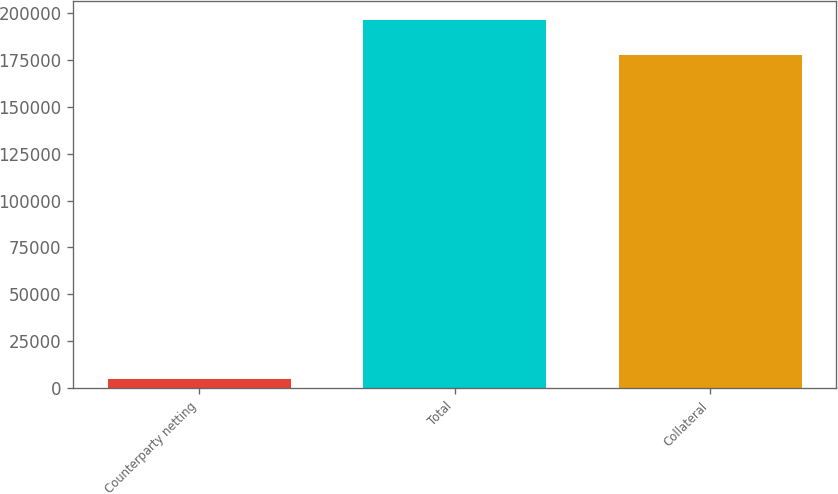Convert chart. <chart><loc_0><loc_0><loc_500><loc_500><bar_chart><fcel>Counterparty netting<fcel>Total<fcel>Collateral<nl><fcel>4935<fcel>196270<fcel>177679<nl></chart> 